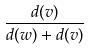Convert formula to latex. <formula><loc_0><loc_0><loc_500><loc_500>\frac { d ( v ) } { d ( w ) + d ( v ) }</formula> 